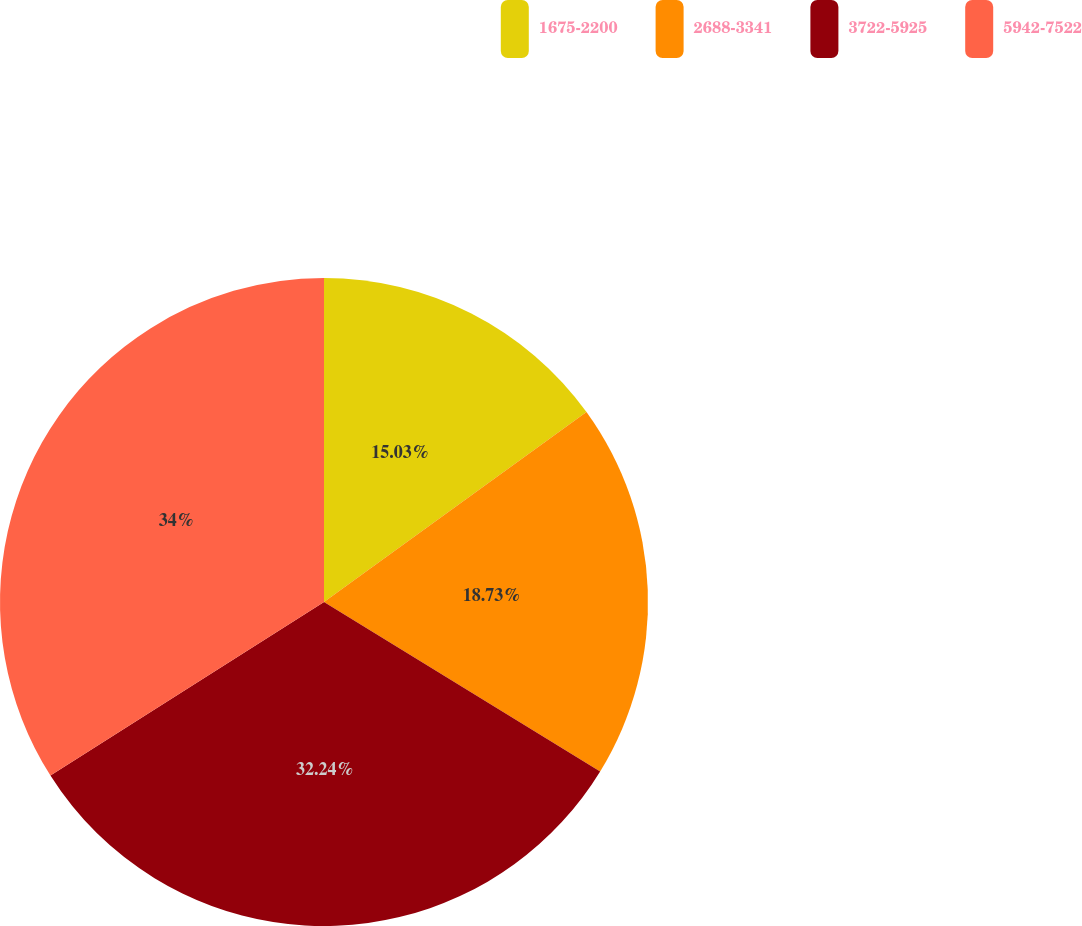Convert chart to OTSL. <chart><loc_0><loc_0><loc_500><loc_500><pie_chart><fcel>1675-2200<fcel>2688-3341<fcel>3722-5925<fcel>5942-7522<nl><fcel>15.03%<fcel>18.73%<fcel>32.24%<fcel>34.0%<nl></chart> 